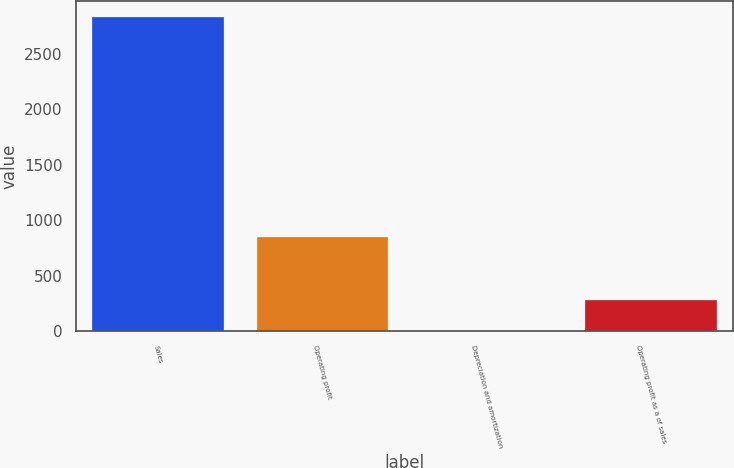Convert chart. <chart><loc_0><loc_0><loc_500><loc_500><bar_chart><fcel>Sales<fcel>Operating profit<fcel>Depreciation and amortization<fcel>Operating profit as a of sales<nl><fcel>2832.9<fcel>852.53<fcel>3.8<fcel>286.71<nl></chart> 